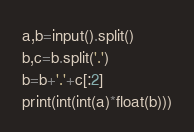Convert code to text. <code><loc_0><loc_0><loc_500><loc_500><_Python_>a,b=input().split()
b,c=b.split('.')
b=b+'.'+c[:2]
print(int(int(a)*float(b)))</code> 